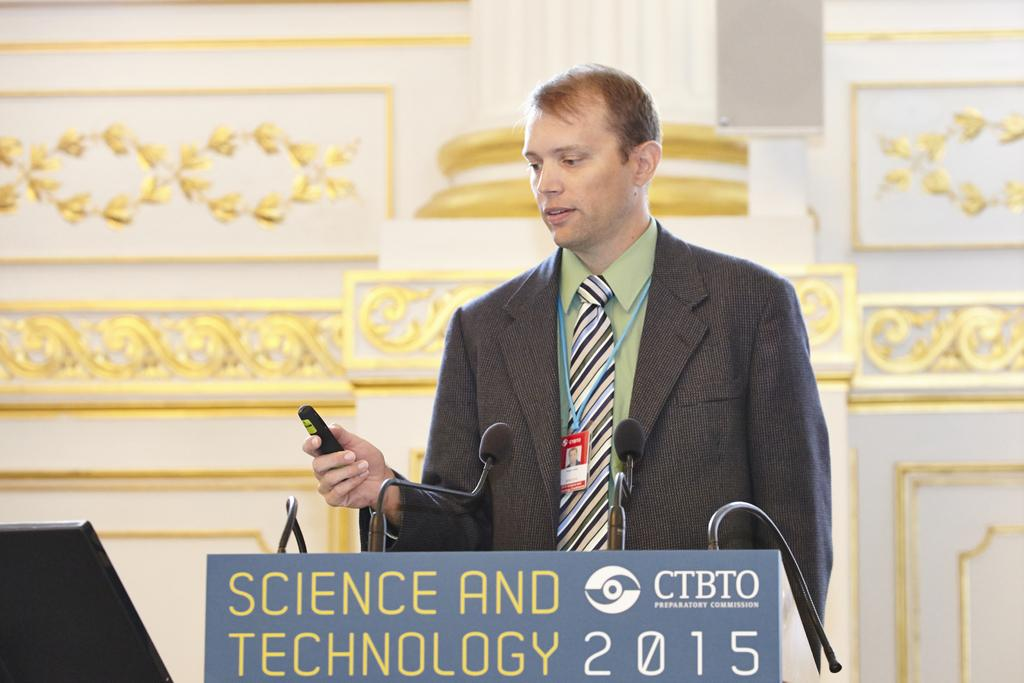What is the person in the image holding? The person in the image is holding a remote. What can be seen on the podium in the image? There are mics on the podium in the image. What is visible in the background of the image? There is a wall in the background of the image. What architectural feature is present in the image? There is a pillar in the image. What type of flower is growing on the pillar in the image? There is no flower growing on the pillar in the image. 